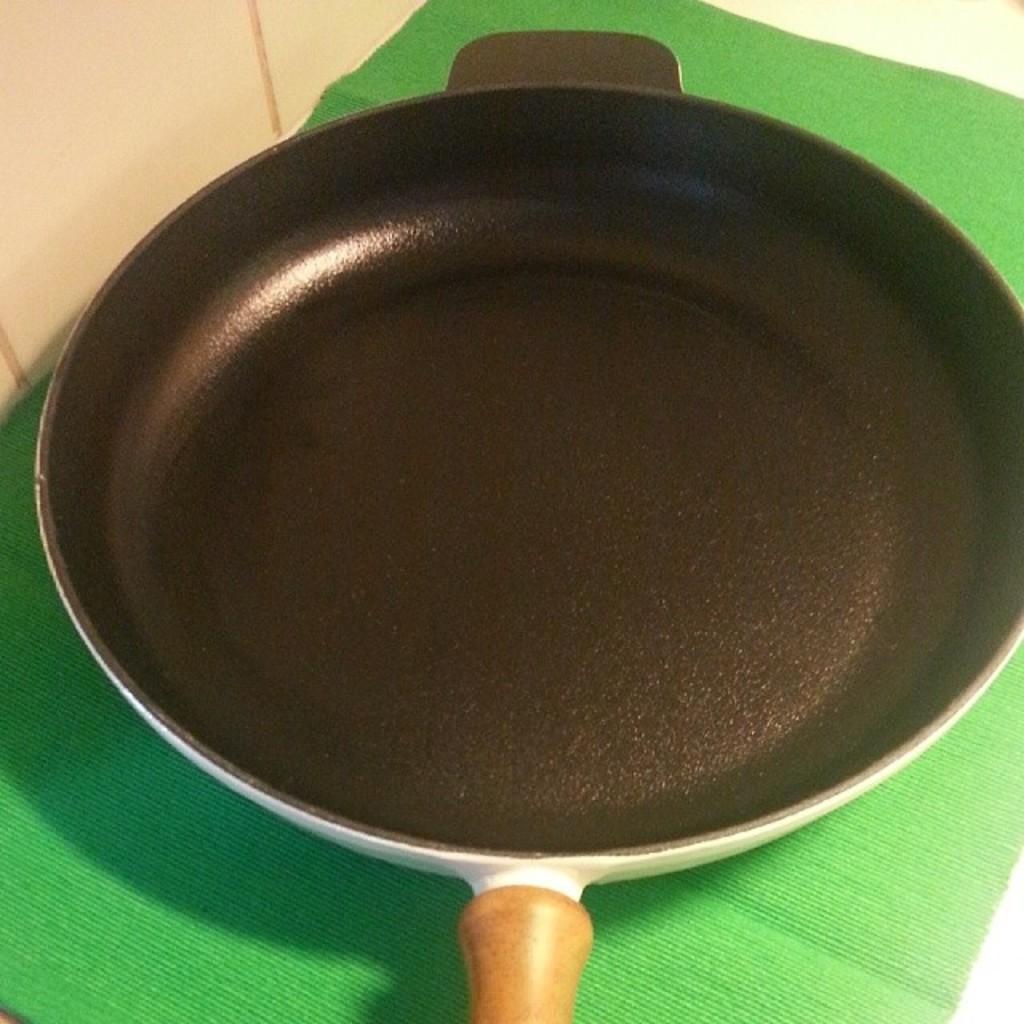Could you give a brief overview of what you see in this image? In this picture I can observe a black color pan placed on the green color mat. On the left side I can observe cream color wall. 